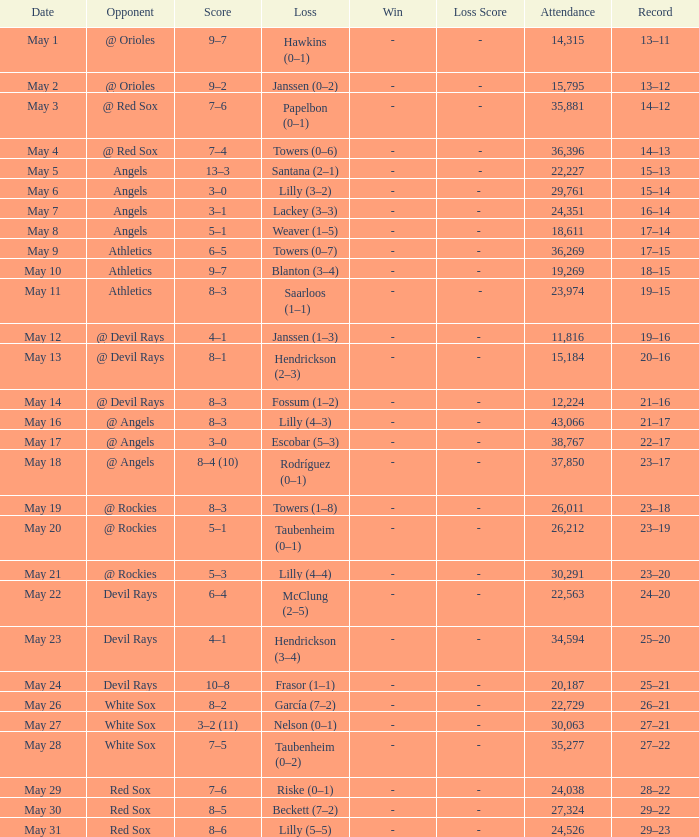With a 16–14 record for the team, what was the aggregate attendance? 1.0. 